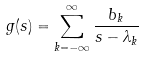<formula> <loc_0><loc_0><loc_500><loc_500>g ( s ) = \sum _ { k = - \infty } ^ { \infty } \frac { b _ { k } } { s - \lambda _ { k } }</formula> 